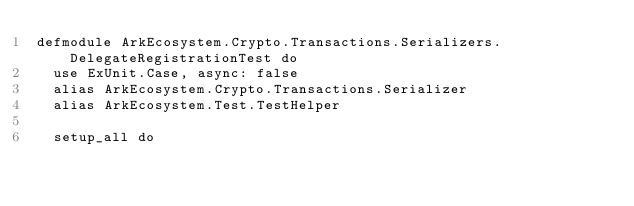<code> <loc_0><loc_0><loc_500><loc_500><_Elixir_>defmodule ArkEcosystem.Crypto.Transactions.Serializers.DelegateRegistrationTest do
  use ExUnit.Case, async: false
  alias ArkEcosystem.Crypto.Transactions.Serializer
  alias ArkEcosystem.Test.TestHelper

  setup_all do</code> 